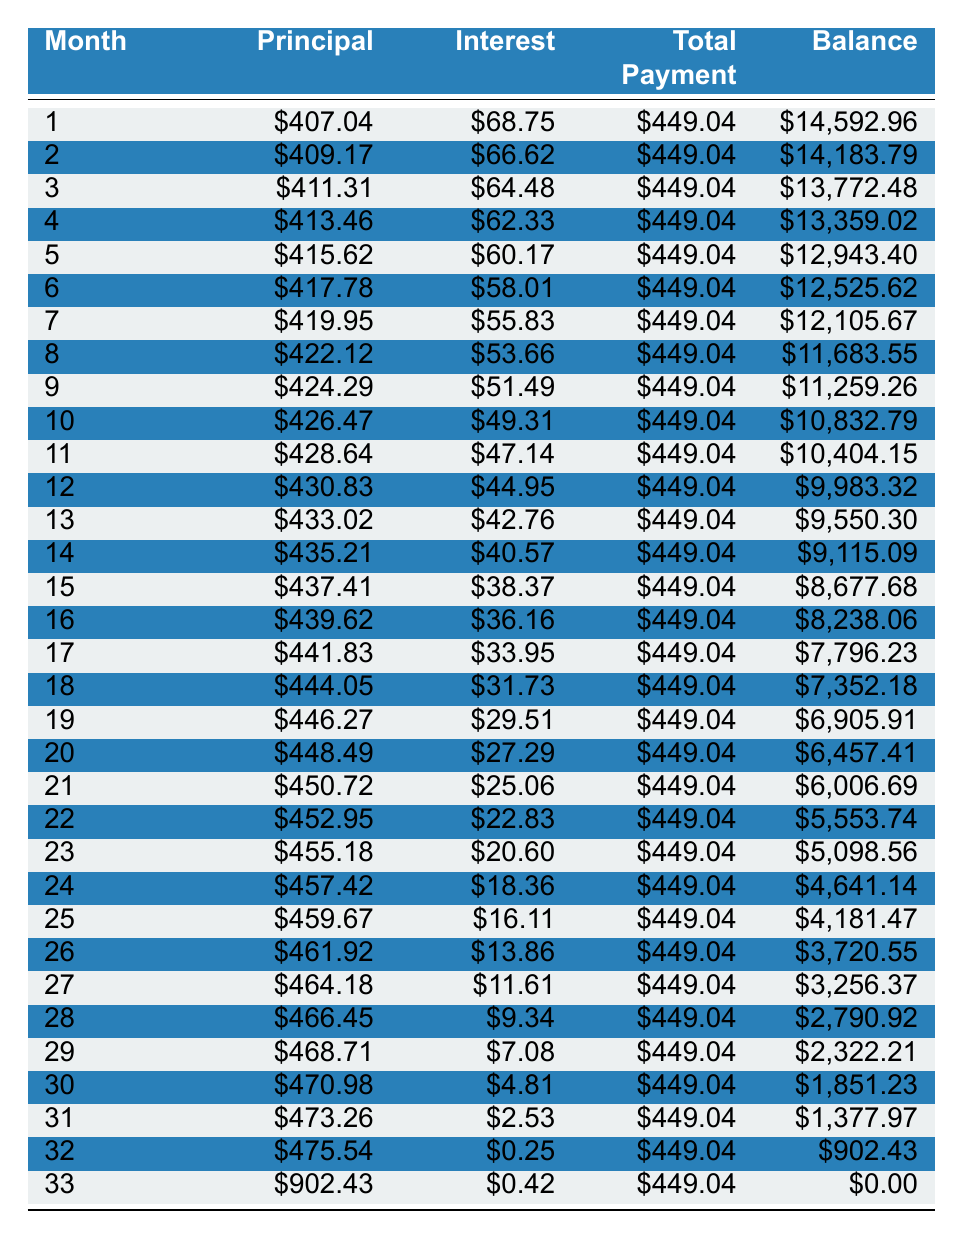What is the total amount paid in the first month? The total payment for the first month is listed under the "Total Payment" column in the first row, which is 449.04.
Answer: 449.04 How much interest is paid in the sixth month? The interest payment for the sixth month is found in the "Interest" column in that row, which is 58.01.
Answer: 58.01 What is the total principal paid after the first three months? To find the total principal paid after three months, we sum the principal payments for the first three months: 407.04 + 409.17 + 411.31 = 1227.52.
Answer: 1227.52 Is the monthly payment the same across all months? All monthly payments are consistently listed as 449.04 across each month, confirming the regular payment structure.
Answer: Yes What is the remaining balance after 12 months? The remaining balance after 12 months is provided in the "Balance" column for that month, listed as 9,983.32.
Answer: 9,983.32 What is the change in the remaining balance from month 5 to month 10? The remaining balance in month 5 is 12,943.40 and in month 10 is 10,832.79. The change is 12,943.40 - 10,832.79 = 2,110.61.
Answer: 2,110.61 How much total principal is paid in the last month? The principal paid in the last month is found in the first column of the last row, which is 902.43.
Answer: 902.43 What is the average monthly interest payment over the entire loan term? The total interest paid over the loan term can be found by summing all interest payments across the months. Then divide by the number of months (36) to find the average. The sum of interest from all payments is 1,021.57; hence, the average is 1,021.57/36 ≈ 28.34.
Answer: 28.34 Is the total payment of 449.04 greater than the total interest paid in any month? By comparing each month's interest payment, we confirm that the total payment exceeds interest in all months since the maximum interest in any month is 68.75, which is less than 449.04.
Answer: Yes 